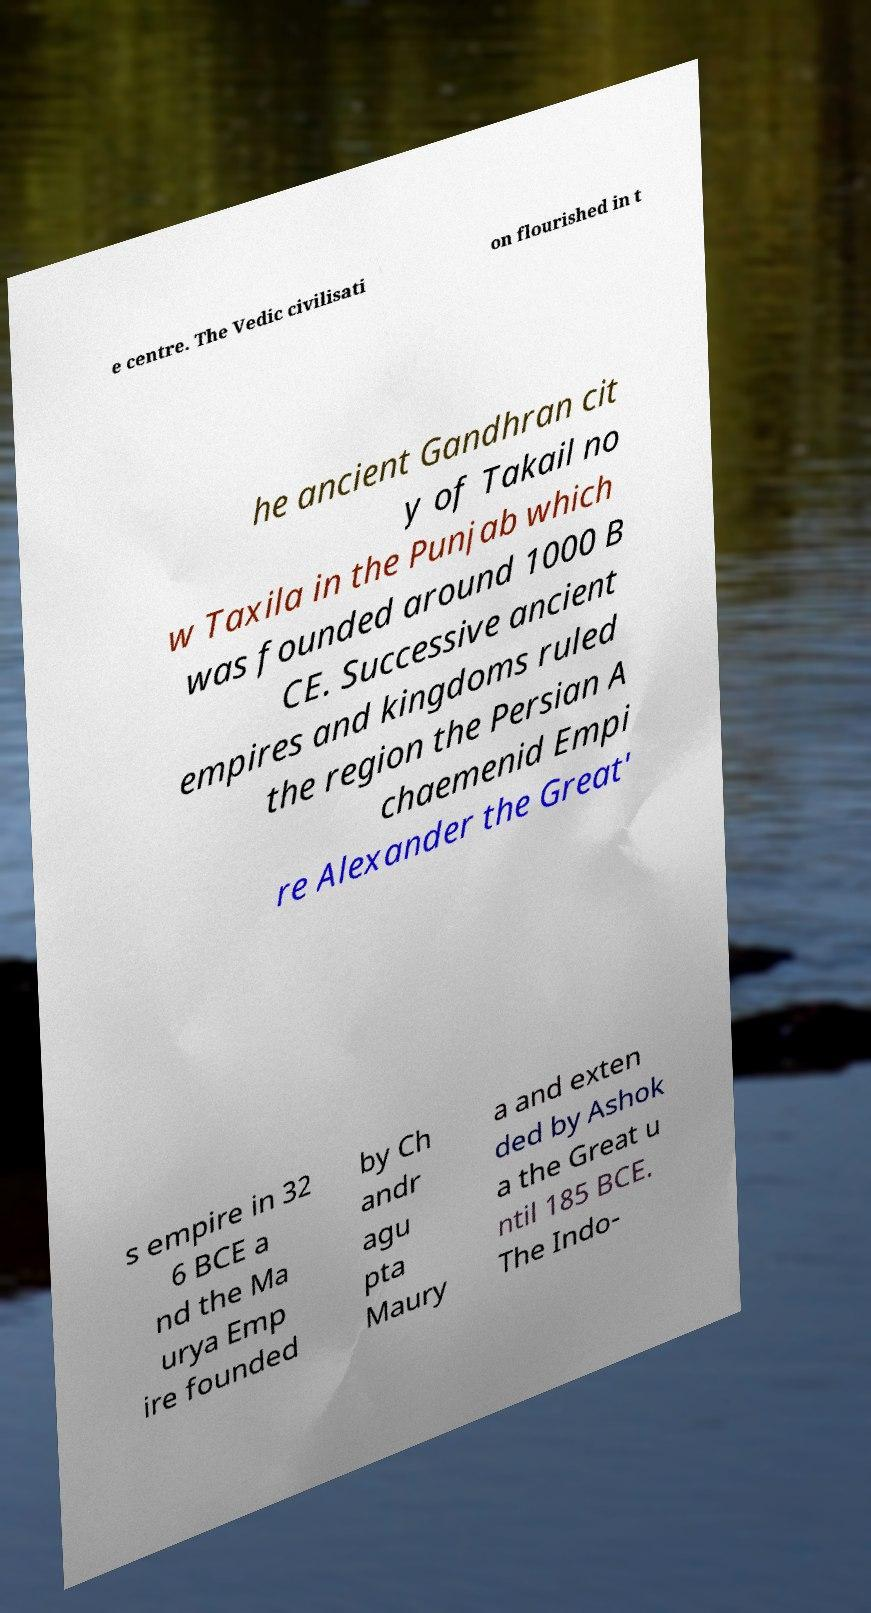I need the written content from this picture converted into text. Can you do that? e centre. The Vedic civilisati on flourished in t he ancient Gandhran cit y of Takail no w Taxila in the Punjab which was founded around 1000 B CE. Successive ancient empires and kingdoms ruled the region the Persian A chaemenid Empi re Alexander the Great' s empire in 32 6 BCE a nd the Ma urya Emp ire founded by Ch andr agu pta Maury a and exten ded by Ashok a the Great u ntil 185 BCE. The Indo- 